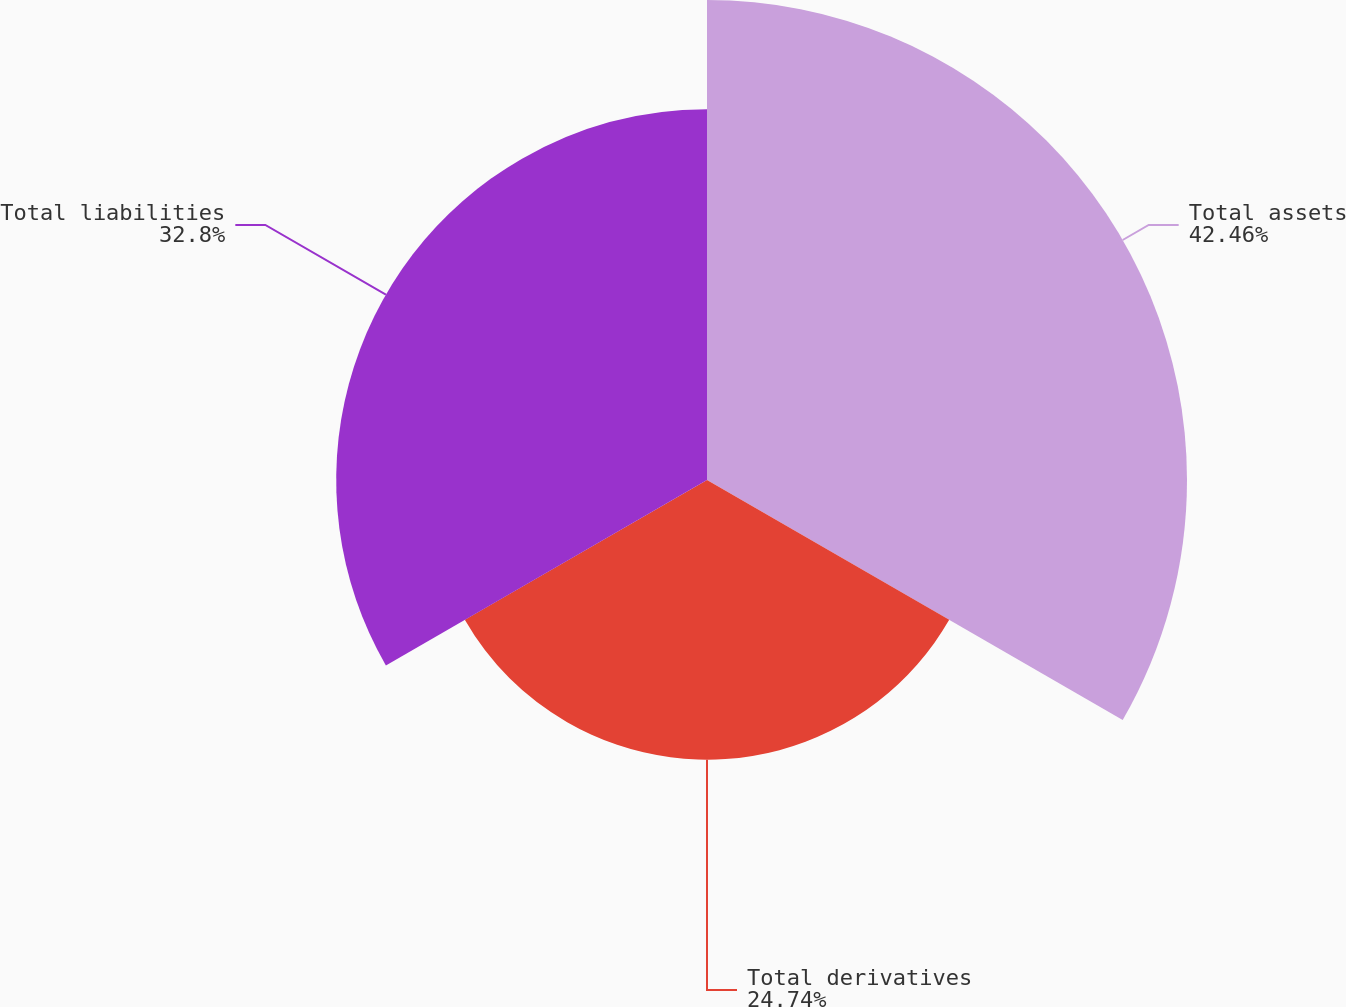<chart> <loc_0><loc_0><loc_500><loc_500><pie_chart><fcel>Total assets<fcel>Total derivatives<fcel>Total liabilities<nl><fcel>42.46%<fcel>24.74%<fcel>32.8%<nl></chart> 